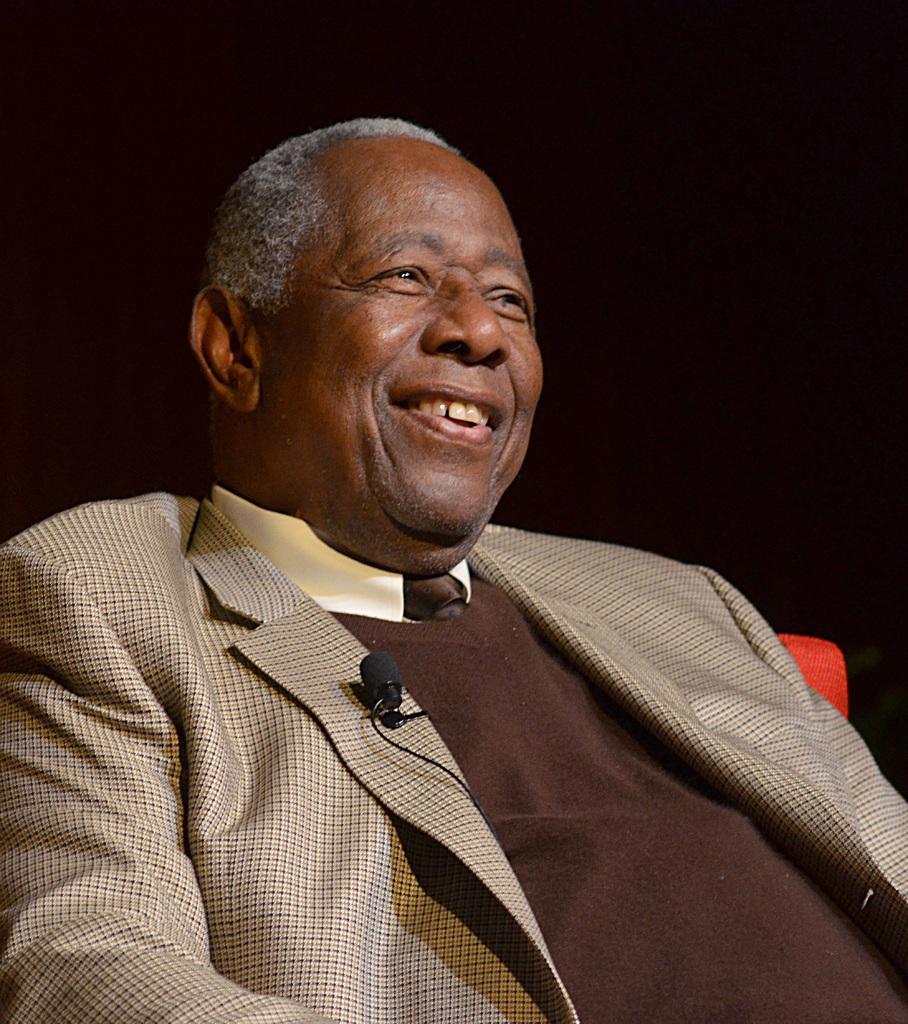Describe this image in one or two sentences. In the image there is a man, he is laughing and the background of the man is dark. 